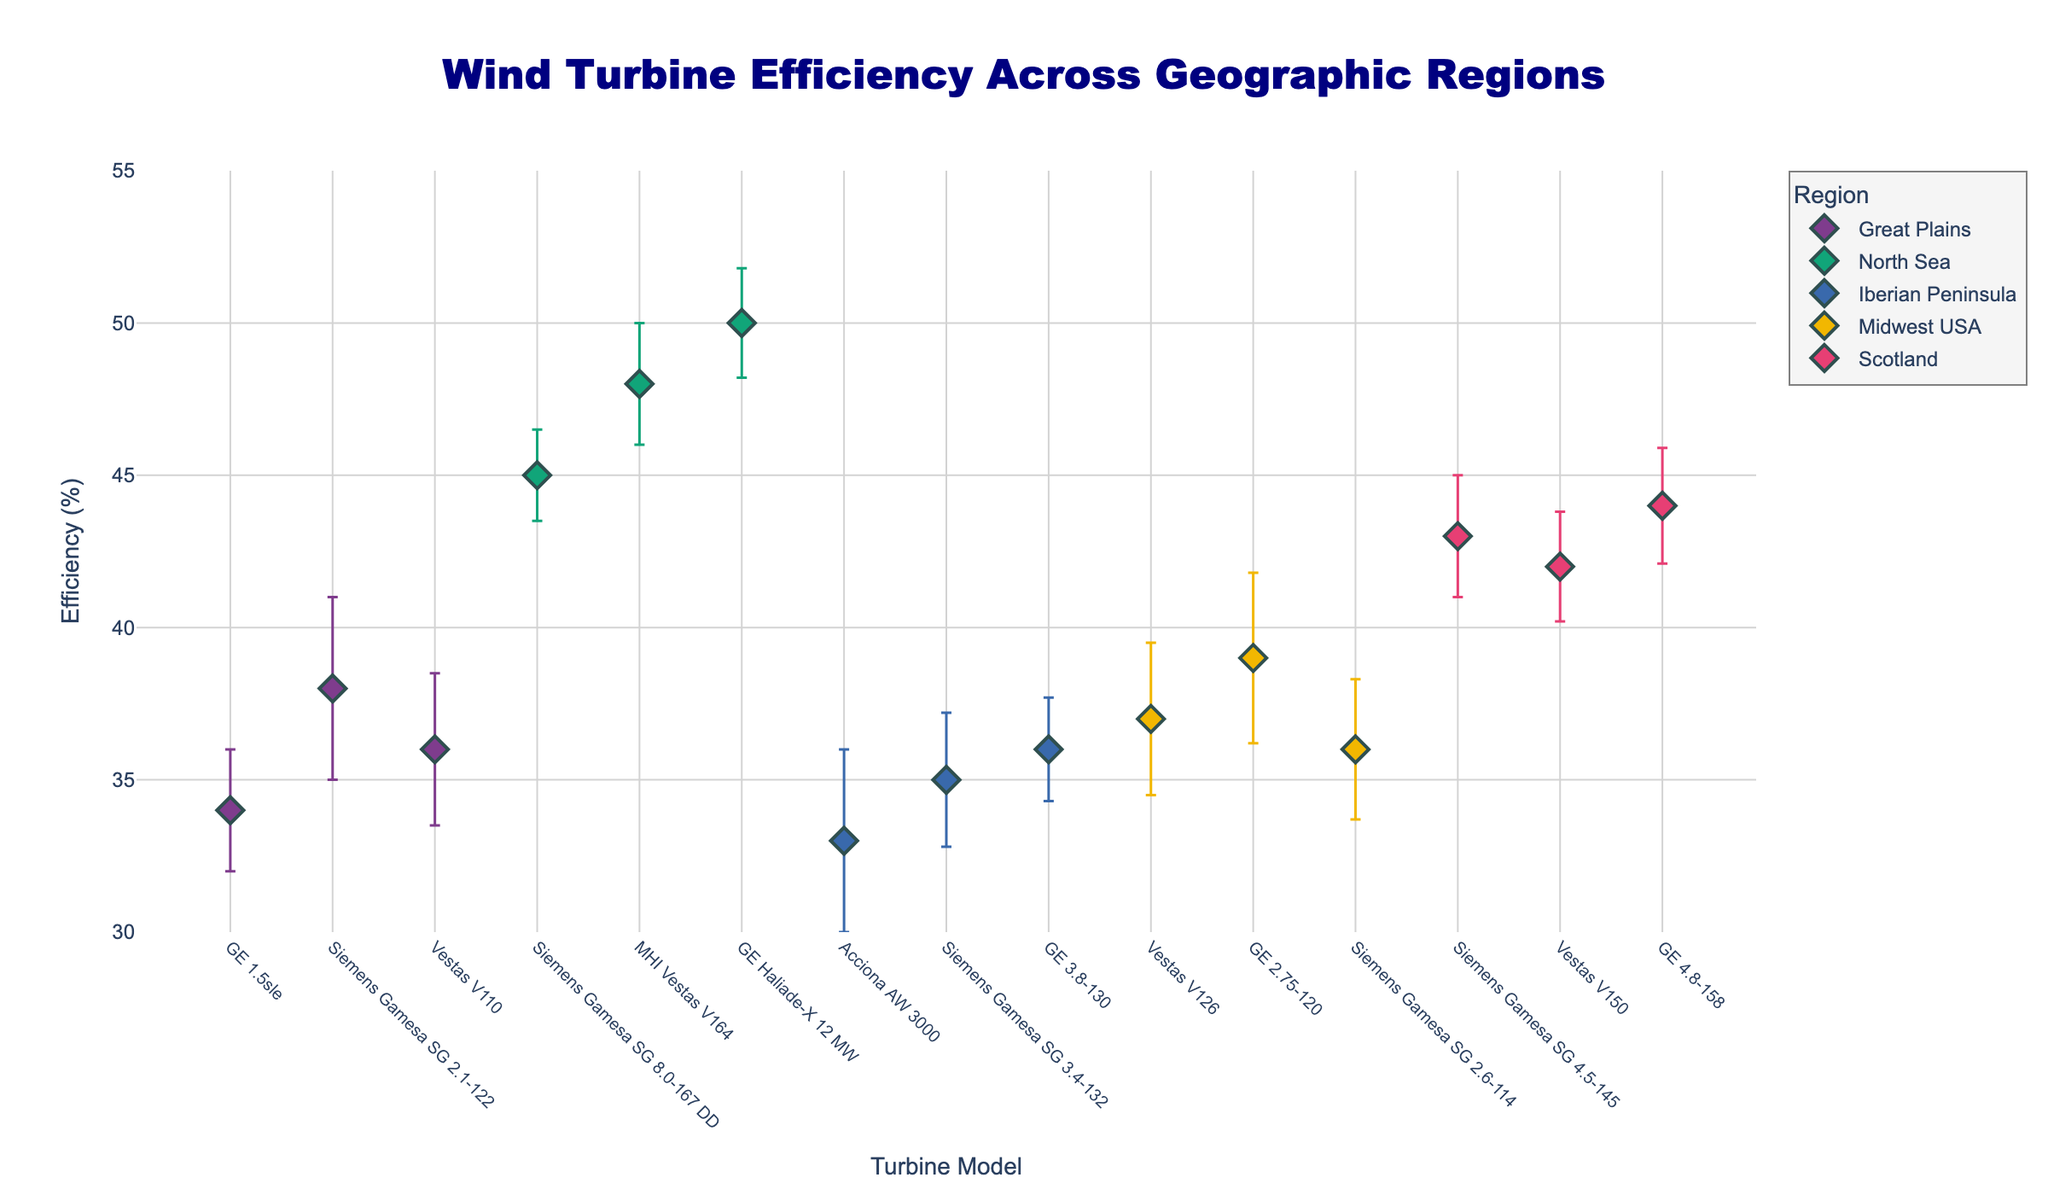What's the title of the plot? The title is directly displayed at the top of the figure in a larger and bold font. It reads: "Wind Turbine Efficiency Across Geographic Regions".
Answer: Wind Turbine Efficiency Across Geographic Regions How many geographic regions are represented in the plot? By examining the legend in the plot, we can see distinct categories represented by different colors. Each category corresponds to a geographic region.
Answer: Five Which turbine model in the North Sea has the highest efficiency? By locating the North Sea data points and checking their efficiency values, we can see that the "GE Haliade-X 12 MW" turbine has an efficiency of 50%, the highest among the North Sea data points.
Answer: GE Haliade-X 12 MW What is the efficiency of the Siemens Gamesa SG 4.5-145 in Scotland? Identify the data points for Scotland in the scatter plot, then find the efficiency for the Siemens Gamesa SG 4.5-145.
Answer: 43% Which region has the largest error margin range for any turbine model? Comparing the error margins of all the data points, the Great Plains has a Siemens Gamesa SG 2.1-122 with a 3% error margin, the highest individual error margin observed.
Answer: Great Plains What is the average efficiency of turbines in the Great Plains? Sum the efficiencies of turbine models in the Great Plains (34, 38, 36) and then divide by the number of data points (3). Avg = (34 + 38 + 36) / 3 = 36%
Answer: 36% Which region has the turbine model with the highest efficiency overall, and what model is it? Identify the highest efficiency value in the entire scatter plot, which is 50% for the GE Haliade-X 12 MW. This model is in the North Sea region.
Answer: North Sea, GE Haliade-X 12 MW Compare the average efficiencies of turbines between the Midwest USA and the Iberian Peninsula. Which region has a higher average efficiency? Calculate the average efficiency for the Midwest USA: (37 + 39 + 36) / 3 = 37.33%. Calculate for the Iberian Peninsula: (33 + 35 + 36) / 3 = 34.67%. The Midwest USA has a higher average.
Answer: Midwest USA Which turbine model has the smallest error margin in the plot, and what is its value? By examining the error bars of all turbine models, the Siemens Gamesa SG 8.0-167 DD in the North Sea has the smallest error margin of 1.5%.
Answer: Siemens Gamesa SG 8.0-167 DD, 1.5% What is the efficiency difference between the highest and lowest efficiency turbin models in the plot? Identify the highest efficiency (50% for GE Haliade-X 12 MW in the North Sea) and the lowest efficiency (33% for Acciona AW 3000 in the Iberian Peninsula). Difference = 50% - 33% = 17%.
Answer: 17% 